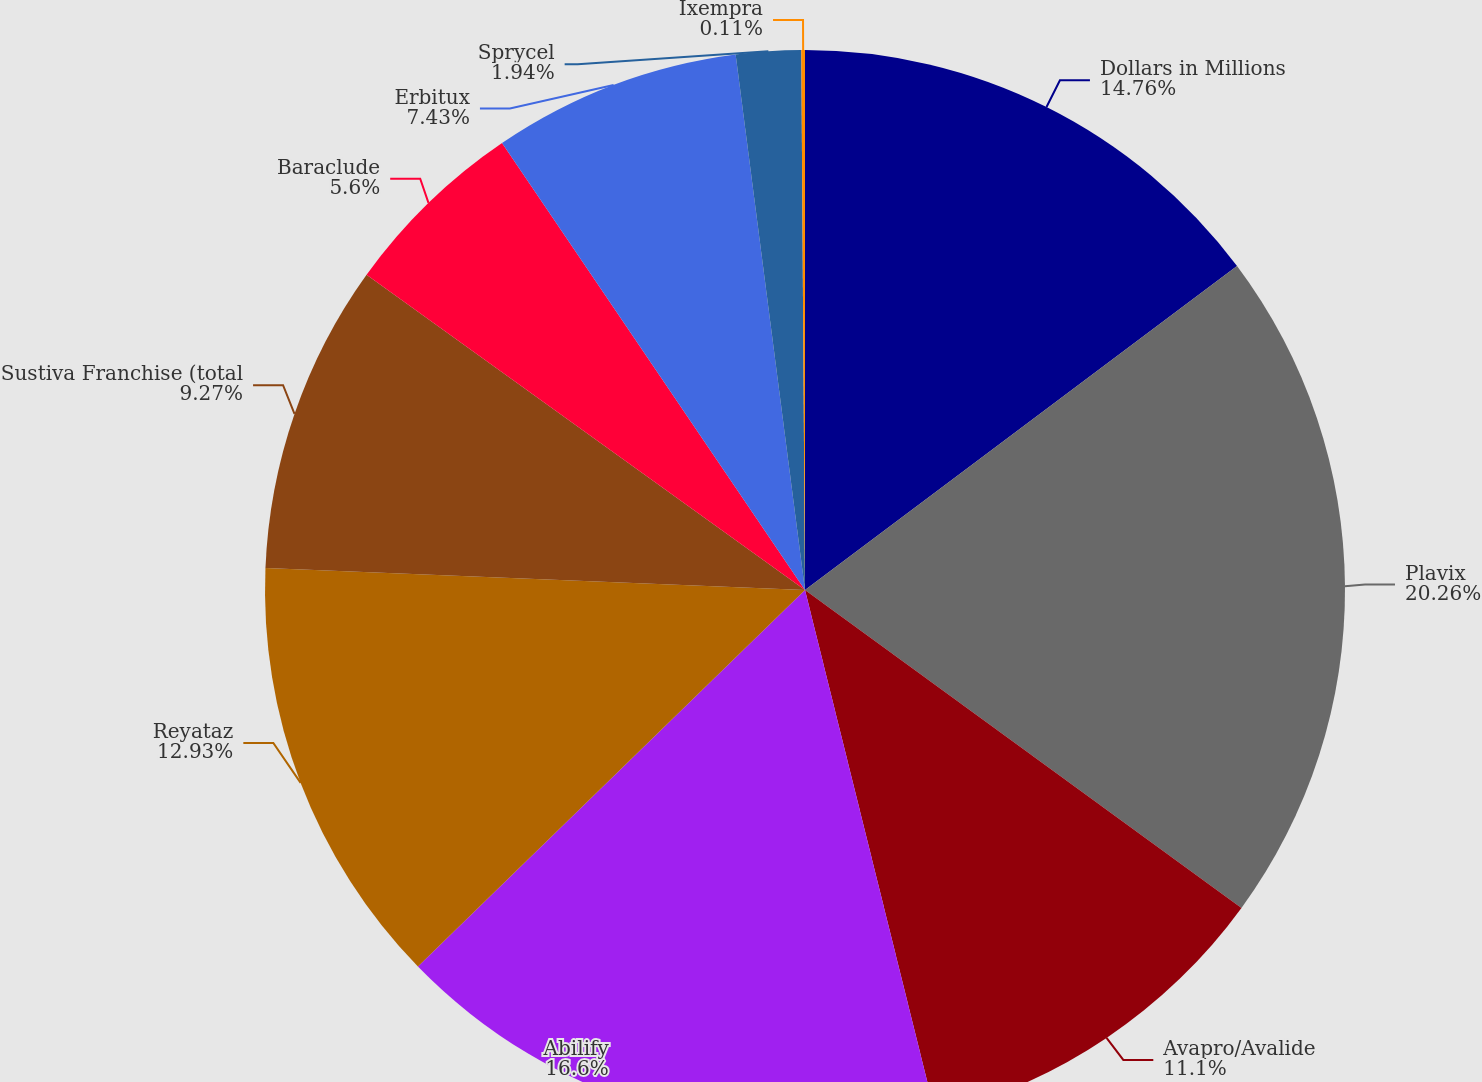Convert chart to OTSL. <chart><loc_0><loc_0><loc_500><loc_500><pie_chart><fcel>Dollars in Millions<fcel>Plavix<fcel>Avapro/Avalide<fcel>Abilify<fcel>Reyataz<fcel>Sustiva Franchise (total<fcel>Baraclude<fcel>Erbitux<fcel>Sprycel<fcel>Ixempra<nl><fcel>14.76%<fcel>20.26%<fcel>11.1%<fcel>16.6%<fcel>12.93%<fcel>9.27%<fcel>5.6%<fcel>7.43%<fcel>1.94%<fcel>0.11%<nl></chart> 